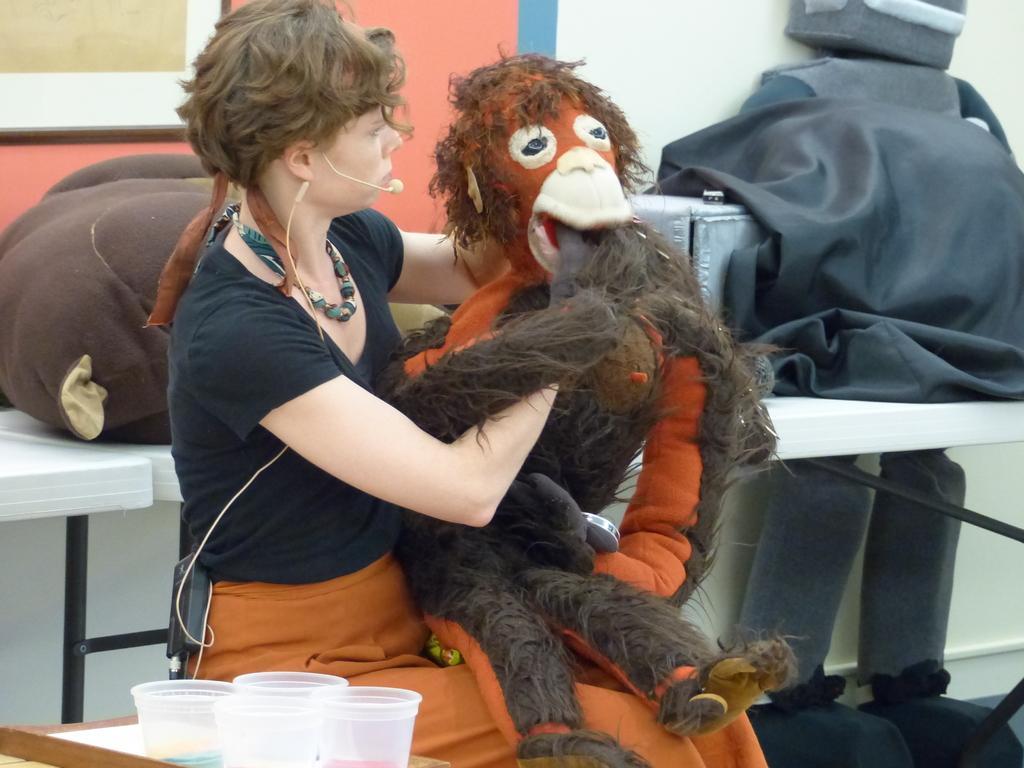Could you give a brief overview of what you see in this image? In this image I can see the toy on the person and the toy is in brown color and the person is wearing black and orange color dress. In the background I can see the cloth in black color and I can also see the wall in white and brown color. 